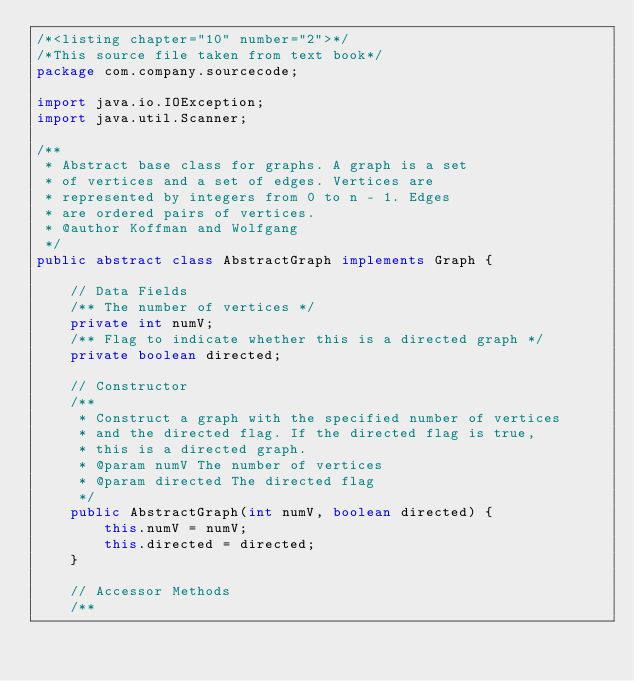<code> <loc_0><loc_0><loc_500><loc_500><_Java_>/*<listing chapter="10" number="2">*/
/*This source file taken from text book*/
package com.company.sourcecode;

import java.io.IOException;
import java.util.Scanner;

/**
 * Abstract base class for graphs. A graph is a set
 * of vertices and a set of edges. Vertices are
 * represented by integers from 0 to n - 1. Edges
 * are ordered pairs of vertices.
 * @author Koffman and Wolfgang
 */
public abstract class AbstractGraph implements Graph {

    // Data Fields
    /** The number of vertices */
    private int numV;
    /** Flag to indicate whether this is a directed graph */
    private boolean directed;

    // Constructor
    /**
     * Construct a graph with the specified number of vertices
     * and the directed flag. If the directed flag is true,
     * this is a directed graph.
     * @param numV The number of vertices
     * @param directed The directed flag
     */
    public AbstractGraph(int numV, boolean directed) {
        this.numV = numV;
        this.directed = directed;
    }

    // Accessor Methods
    /**</code> 